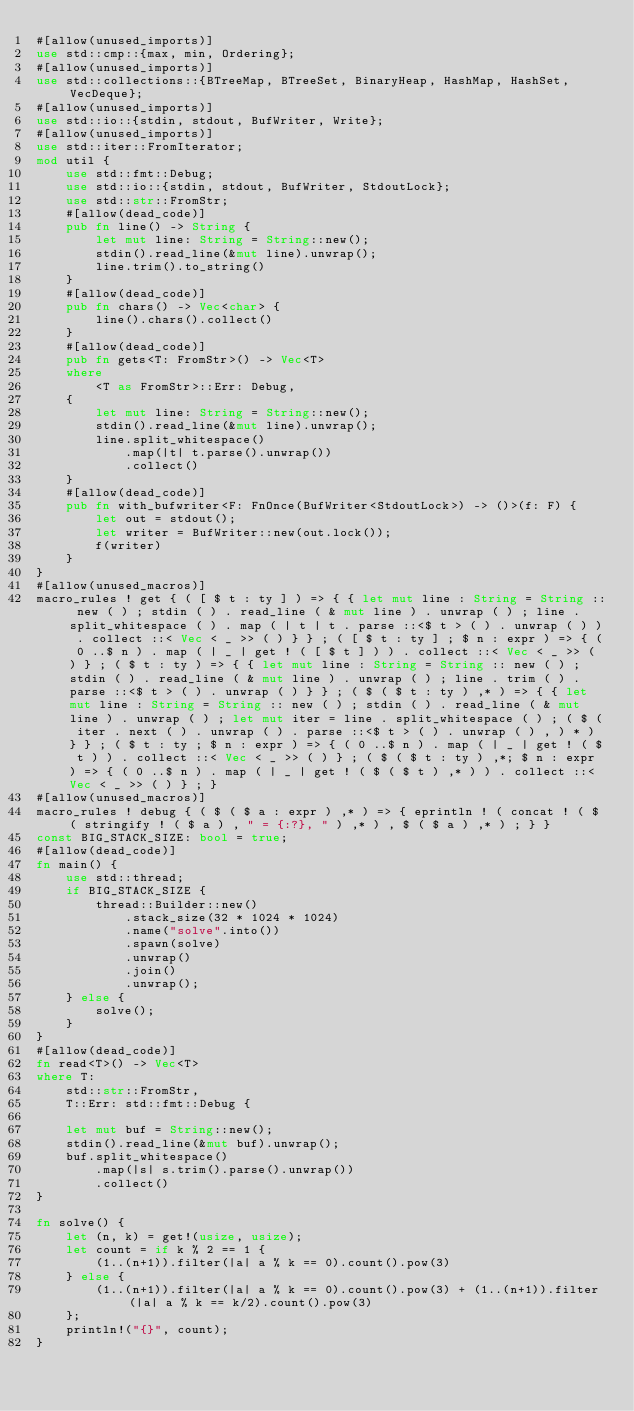<code> <loc_0><loc_0><loc_500><loc_500><_Rust_>#[allow(unused_imports)]
use std::cmp::{max, min, Ordering};
#[allow(unused_imports)]
use std::collections::{BTreeMap, BTreeSet, BinaryHeap, HashMap, HashSet, VecDeque};
#[allow(unused_imports)]
use std::io::{stdin, stdout, BufWriter, Write};
#[allow(unused_imports)]
use std::iter::FromIterator;
mod util {
    use std::fmt::Debug;
    use std::io::{stdin, stdout, BufWriter, StdoutLock};
    use std::str::FromStr;
    #[allow(dead_code)]
    pub fn line() -> String {
        let mut line: String = String::new();
        stdin().read_line(&mut line).unwrap();
        line.trim().to_string()
    }
    #[allow(dead_code)]
    pub fn chars() -> Vec<char> {
        line().chars().collect()
    }
    #[allow(dead_code)]
    pub fn gets<T: FromStr>() -> Vec<T>
    where
        <T as FromStr>::Err: Debug,
    {
        let mut line: String = String::new();
        stdin().read_line(&mut line).unwrap();
        line.split_whitespace()
            .map(|t| t.parse().unwrap())
            .collect()
    }
    #[allow(dead_code)]
    pub fn with_bufwriter<F: FnOnce(BufWriter<StdoutLock>) -> ()>(f: F) {
        let out = stdout();
        let writer = BufWriter::new(out.lock());
        f(writer)
    }
}
#[allow(unused_macros)]
macro_rules ! get { ( [ $ t : ty ] ) => { { let mut line : String = String :: new ( ) ; stdin ( ) . read_line ( & mut line ) . unwrap ( ) ; line . split_whitespace ( ) . map ( | t | t . parse ::<$ t > ( ) . unwrap ( ) ) . collect ::< Vec < _ >> ( ) } } ; ( [ $ t : ty ] ; $ n : expr ) => { ( 0 ..$ n ) . map ( | _ | get ! ( [ $ t ] ) ) . collect ::< Vec < _ >> ( ) } ; ( $ t : ty ) => { { let mut line : String = String :: new ( ) ; stdin ( ) . read_line ( & mut line ) . unwrap ( ) ; line . trim ( ) . parse ::<$ t > ( ) . unwrap ( ) } } ; ( $ ( $ t : ty ) ,* ) => { { let mut line : String = String :: new ( ) ; stdin ( ) . read_line ( & mut line ) . unwrap ( ) ; let mut iter = line . split_whitespace ( ) ; ( $ ( iter . next ( ) . unwrap ( ) . parse ::<$ t > ( ) . unwrap ( ) , ) * ) } } ; ( $ t : ty ; $ n : expr ) => { ( 0 ..$ n ) . map ( | _ | get ! ( $ t ) ) . collect ::< Vec < _ >> ( ) } ; ( $ ( $ t : ty ) ,*; $ n : expr ) => { ( 0 ..$ n ) . map ( | _ | get ! ( $ ( $ t ) ,* ) ) . collect ::< Vec < _ >> ( ) } ; }
#[allow(unused_macros)]
macro_rules ! debug { ( $ ( $ a : expr ) ,* ) => { eprintln ! ( concat ! ( $ ( stringify ! ( $ a ) , " = {:?}, " ) ,* ) , $ ( $ a ) ,* ) ; } }
const BIG_STACK_SIZE: bool = true;
#[allow(dead_code)]
fn main() {
    use std::thread;
    if BIG_STACK_SIZE {
        thread::Builder::new()
            .stack_size(32 * 1024 * 1024)
            .name("solve".into())
            .spawn(solve)
            .unwrap()
            .join()
            .unwrap();
    } else {
        solve();
    }
}
#[allow(dead_code)]
fn read<T>() -> Vec<T>
where T:
    std::str::FromStr,
    T::Err: std::fmt::Debug {

    let mut buf = String::new();
    stdin().read_line(&mut buf).unwrap();
    buf.split_whitespace()
        .map(|s| s.trim().parse().unwrap())
        .collect()
}

fn solve() {
    let (n, k) = get!(usize, usize);
    let count = if k % 2 == 1 {
        (1..(n+1)).filter(|a| a % k == 0).count().pow(3)
    } else {
        (1..(n+1)).filter(|a| a % k == 0).count().pow(3) + (1..(n+1)).filter(|a| a % k == k/2).count().pow(3)
    };
    println!("{}", count);
}
</code> 